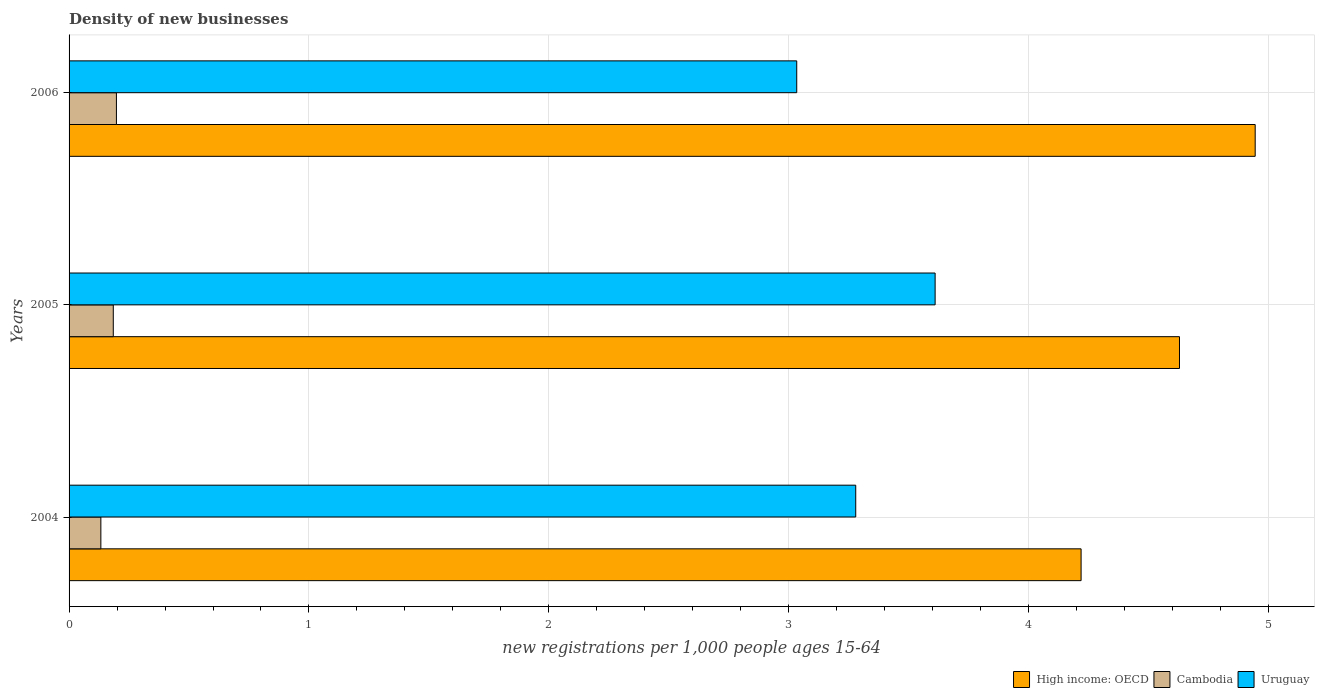How many groups of bars are there?
Your response must be concise. 3. How many bars are there on the 3rd tick from the bottom?
Keep it short and to the point. 3. What is the label of the 2nd group of bars from the top?
Offer a terse response. 2005. In how many cases, is the number of bars for a given year not equal to the number of legend labels?
Provide a short and direct response. 0. What is the number of new registrations in Uruguay in 2005?
Provide a succinct answer. 3.61. Across all years, what is the maximum number of new registrations in Uruguay?
Ensure brevity in your answer.  3.61. Across all years, what is the minimum number of new registrations in High income: OECD?
Your answer should be very brief. 4.22. In which year was the number of new registrations in Uruguay maximum?
Provide a succinct answer. 2005. What is the total number of new registrations in Uruguay in the graph?
Provide a short and direct response. 9.92. What is the difference between the number of new registrations in Uruguay in 2004 and that in 2005?
Give a very brief answer. -0.33. What is the difference between the number of new registrations in Uruguay in 2004 and the number of new registrations in Cambodia in 2005?
Provide a succinct answer. 3.1. What is the average number of new registrations in Cambodia per year?
Give a very brief answer. 0.17. In the year 2005, what is the difference between the number of new registrations in Cambodia and number of new registrations in High income: OECD?
Your answer should be compact. -4.44. In how many years, is the number of new registrations in Cambodia greater than 3.2 ?
Provide a succinct answer. 0. What is the ratio of the number of new registrations in Cambodia in 2004 to that in 2006?
Offer a very short reply. 0.67. Is the number of new registrations in Cambodia in 2005 less than that in 2006?
Give a very brief answer. Yes. Is the difference between the number of new registrations in Cambodia in 2005 and 2006 greater than the difference between the number of new registrations in High income: OECD in 2005 and 2006?
Keep it short and to the point. Yes. What is the difference between the highest and the second highest number of new registrations in High income: OECD?
Provide a short and direct response. 0.32. What is the difference between the highest and the lowest number of new registrations in High income: OECD?
Your answer should be very brief. 0.73. What does the 3rd bar from the top in 2005 represents?
Offer a very short reply. High income: OECD. What does the 2nd bar from the bottom in 2005 represents?
Provide a succinct answer. Cambodia. How many bars are there?
Keep it short and to the point. 9. Are all the bars in the graph horizontal?
Ensure brevity in your answer.  Yes. Does the graph contain any zero values?
Give a very brief answer. No. How many legend labels are there?
Provide a short and direct response. 3. What is the title of the graph?
Provide a succinct answer. Density of new businesses. Does "South Sudan" appear as one of the legend labels in the graph?
Make the answer very short. No. What is the label or title of the X-axis?
Keep it short and to the point. New registrations per 1,0 people ages 15-64. What is the new registrations per 1,000 people ages 15-64 of High income: OECD in 2004?
Provide a succinct answer. 4.22. What is the new registrations per 1,000 people ages 15-64 in Cambodia in 2004?
Ensure brevity in your answer.  0.13. What is the new registrations per 1,000 people ages 15-64 of Uruguay in 2004?
Ensure brevity in your answer.  3.28. What is the new registrations per 1,000 people ages 15-64 of High income: OECD in 2005?
Your answer should be very brief. 4.63. What is the new registrations per 1,000 people ages 15-64 in Cambodia in 2005?
Ensure brevity in your answer.  0.18. What is the new registrations per 1,000 people ages 15-64 in Uruguay in 2005?
Make the answer very short. 3.61. What is the new registrations per 1,000 people ages 15-64 of High income: OECD in 2006?
Ensure brevity in your answer.  4.94. What is the new registrations per 1,000 people ages 15-64 in Cambodia in 2006?
Your response must be concise. 0.2. What is the new registrations per 1,000 people ages 15-64 of Uruguay in 2006?
Provide a succinct answer. 3.03. Across all years, what is the maximum new registrations per 1,000 people ages 15-64 of High income: OECD?
Provide a short and direct response. 4.94. Across all years, what is the maximum new registrations per 1,000 people ages 15-64 of Cambodia?
Provide a succinct answer. 0.2. Across all years, what is the maximum new registrations per 1,000 people ages 15-64 of Uruguay?
Your response must be concise. 3.61. Across all years, what is the minimum new registrations per 1,000 people ages 15-64 of High income: OECD?
Make the answer very short. 4.22. Across all years, what is the minimum new registrations per 1,000 people ages 15-64 in Cambodia?
Ensure brevity in your answer.  0.13. Across all years, what is the minimum new registrations per 1,000 people ages 15-64 of Uruguay?
Give a very brief answer. 3.03. What is the total new registrations per 1,000 people ages 15-64 of High income: OECD in the graph?
Your answer should be very brief. 13.79. What is the total new registrations per 1,000 people ages 15-64 in Cambodia in the graph?
Your response must be concise. 0.51. What is the total new registrations per 1,000 people ages 15-64 in Uruguay in the graph?
Your response must be concise. 9.92. What is the difference between the new registrations per 1,000 people ages 15-64 in High income: OECD in 2004 and that in 2005?
Your response must be concise. -0.41. What is the difference between the new registrations per 1,000 people ages 15-64 in Cambodia in 2004 and that in 2005?
Make the answer very short. -0.05. What is the difference between the new registrations per 1,000 people ages 15-64 of Uruguay in 2004 and that in 2005?
Keep it short and to the point. -0.33. What is the difference between the new registrations per 1,000 people ages 15-64 in High income: OECD in 2004 and that in 2006?
Make the answer very short. -0.73. What is the difference between the new registrations per 1,000 people ages 15-64 in Cambodia in 2004 and that in 2006?
Offer a very short reply. -0.06. What is the difference between the new registrations per 1,000 people ages 15-64 of Uruguay in 2004 and that in 2006?
Make the answer very short. 0.25. What is the difference between the new registrations per 1,000 people ages 15-64 of High income: OECD in 2005 and that in 2006?
Your answer should be compact. -0.32. What is the difference between the new registrations per 1,000 people ages 15-64 of Cambodia in 2005 and that in 2006?
Make the answer very short. -0.01. What is the difference between the new registrations per 1,000 people ages 15-64 of Uruguay in 2005 and that in 2006?
Ensure brevity in your answer.  0.58. What is the difference between the new registrations per 1,000 people ages 15-64 of High income: OECD in 2004 and the new registrations per 1,000 people ages 15-64 of Cambodia in 2005?
Offer a terse response. 4.03. What is the difference between the new registrations per 1,000 people ages 15-64 in High income: OECD in 2004 and the new registrations per 1,000 people ages 15-64 in Uruguay in 2005?
Your response must be concise. 0.61. What is the difference between the new registrations per 1,000 people ages 15-64 in Cambodia in 2004 and the new registrations per 1,000 people ages 15-64 in Uruguay in 2005?
Make the answer very short. -3.48. What is the difference between the new registrations per 1,000 people ages 15-64 in High income: OECD in 2004 and the new registrations per 1,000 people ages 15-64 in Cambodia in 2006?
Keep it short and to the point. 4.02. What is the difference between the new registrations per 1,000 people ages 15-64 in High income: OECD in 2004 and the new registrations per 1,000 people ages 15-64 in Uruguay in 2006?
Make the answer very short. 1.19. What is the difference between the new registrations per 1,000 people ages 15-64 of Cambodia in 2004 and the new registrations per 1,000 people ages 15-64 of Uruguay in 2006?
Provide a succinct answer. -2.9. What is the difference between the new registrations per 1,000 people ages 15-64 of High income: OECD in 2005 and the new registrations per 1,000 people ages 15-64 of Cambodia in 2006?
Give a very brief answer. 4.43. What is the difference between the new registrations per 1,000 people ages 15-64 in High income: OECD in 2005 and the new registrations per 1,000 people ages 15-64 in Uruguay in 2006?
Your response must be concise. 1.6. What is the difference between the new registrations per 1,000 people ages 15-64 of Cambodia in 2005 and the new registrations per 1,000 people ages 15-64 of Uruguay in 2006?
Give a very brief answer. -2.85. What is the average new registrations per 1,000 people ages 15-64 in High income: OECD per year?
Offer a very short reply. 4.6. What is the average new registrations per 1,000 people ages 15-64 of Cambodia per year?
Keep it short and to the point. 0.17. What is the average new registrations per 1,000 people ages 15-64 in Uruguay per year?
Provide a short and direct response. 3.31. In the year 2004, what is the difference between the new registrations per 1,000 people ages 15-64 in High income: OECD and new registrations per 1,000 people ages 15-64 in Cambodia?
Your answer should be very brief. 4.09. In the year 2004, what is the difference between the new registrations per 1,000 people ages 15-64 of High income: OECD and new registrations per 1,000 people ages 15-64 of Uruguay?
Keep it short and to the point. 0.94. In the year 2004, what is the difference between the new registrations per 1,000 people ages 15-64 in Cambodia and new registrations per 1,000 people ages 15-64 in Uruguay?
Give a very brief answer. -3.15. In the year 2005, what is the difference between the new registrations per 1,000 people ages 15-64 of High income: OECD and new registrations per 1,000 people ages 15-64 of Cambodia?
Your answer should be very brief. 4.44. In the year 2005, what is the difference between the new registrations per 1,000 people ages 15-64 of High income: OECD and new registrations per 1,000 people ages 15-64 of Uruguay?
Give a very brief answer. 1.02. In the year 2005, what is the difference between the new registrations per 1,000 people ages 15-64 in Cambodia and new registrations per 1,000 people ages 15-64 in Uruguay?
Provide a succinct answer. -3.43. In the year 2006, what is the difference between the new registrations per 1,000 people ages 15-64 of High income: OECD and new registrations per 1,000 people ages 15-64 of Cambodia?
Your response must be concise. 4.75. In the year 2006, what is the difference between the new registrations per 1,000 people ages 15-64 of High income: OECD and new registrations per 1,000 people ages 15-64 of Uruguay?
Keep it short and to the point. 1.91. In the year 2006, what is the difference between the new registrations per 1,000 people ages 15-64 in Cambodia and new registrations per 1,000 people ages 15-64 in Uruguay?
Give a very brief answer. -2.84. What is the ratio of the new registrations per 1,000 people ages 15-64 in High income: OECD in 2004 to that in 2005?
Offer a terse response. 0.91. What is the ratio of the new registrations per 1,000 people ages 15-64 of Cambodia in 2004 to that in 2005?
Your answer should be compact. 0.72. What is the ratio of the new registrations per 1,000 people ages 15-64 in Uruguay in 2004 to that in 2005?
Keep it short and to the point. 0.91. What is the ratio of the new registrations per 1,000 people ages 15-64 of High income: OECD in 2004 to that in 2006?
Provide a succinct answer. 0.85. What is the ratio of the new registrations per 1,000 people ages 15-64 in Cambodia in 2004 to that in 2006?
Ensure brevity in your answer.  0.67. What is the ratio of the new registrations per 1,000 people ages 15-64 in Uruguay in 2004 to that in 2006?
Ensure brevity in your answer.  1.08. What is the ratio of the new registrations per 1,000 people ages 15-64 in High income: OECD in 2005 to that in 2006?
Your answer should be compact. 0.94. What is the ratio of the new registrations per 1,000 people ages 15-64 of Cambodia in 2005 to that in 2006?
Ensure brevity in your answer.  0.93. What is the ratio of the new registrations per 1,000 people ages 15-64 in Uruguay in 2005 to that in 2006?
Offer a very short reply. 1.19. What is the difference between the highest and the second highest new registrations per 1,000 people ages 15-64 of High income: OECD?
Ensure brevity in your answer.  0.32. What is the difference between the highest and the second highest new registrations per 1,000 people ages 15-64 of Cambodia?
Give a very brief answer. 0.01. What is the difference between the highest and the second highest new registrations per 1,000 people ages 15-64 of Uruguay?
Your answer should be compact. 0.33. What is the difference between the highest and the lowest new registrations per 1,000 people ages 15-64 of High income: OECD?
Make the answer very short. 0.73. What is the difference between the highest and the lowest new registrations per 1,000 people ages 15-64 of Cambodia?
Your answer should be compact. 0.06. What is the difference between the highest and the lowest new registrations per 1,000 people ages 15-64 in Uruguay?
Offer a very short reply. 0.58. 